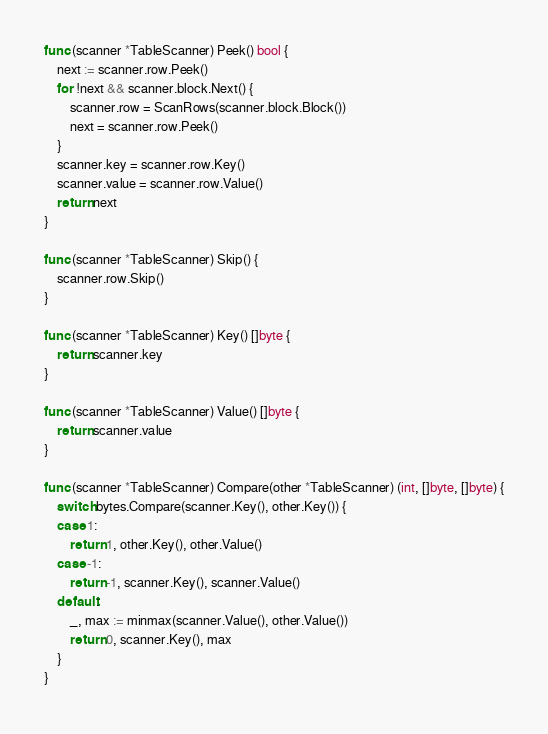Convert code to text. <code><loc_0><loc_0><loc_500><loc_500><_Go_>
func (scanner *TableScanner) Peek() bool {
	next := scanner.row.Peek()
	for !next && scanner.block.Next() {
		scanner.row = ScanRows(scanner.block.Block())
		next = scanner.row.Peek()
	}
	scanner.key = scanner.row.Key()
	scanner.value = scanner.row.Value()
	return next
}

func (scanner *TableScanner) Skip() {
	scanner.row.Skip()
}

func (scanner *TableScanner) Key() []byte {
	return scanner.key
}

func (scanner *TableScanner) Value() []byte {
	return scanner.value
}

func (scanner *TableScanner) Compare(other *TableScanner) (int, []byte, []byte) {
	switch bytes.Compare(scanner.Key(), other.Key()) {
	case 1:
		return 1, other.Key(), other.Value()
	case -1:
		return -1, scanner.Key(), scanner.Value()
	default:
		_, max := minmax(scanner.Value(), other.Value())
		return 0, scanner.Key(), max
	}
}
</code> 